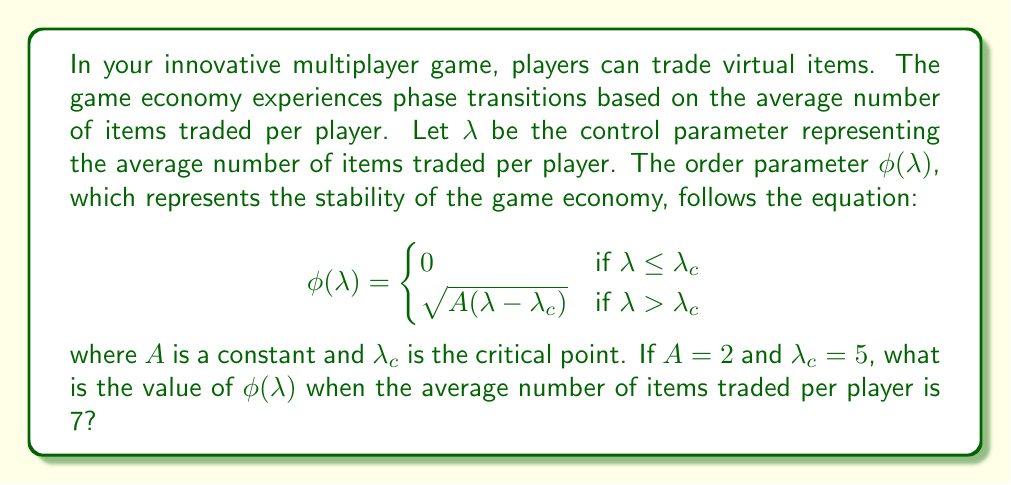Could you help me with this problem? Let's approach this step-by-step:

1) We're given that $A = 2$ and $\lambda_c = 5$.

2) We need to find $\phi(\lambda)$ when $\lambda = 7$.

3) First, we need to determine which case of the piecewise function we're in:
   $\lambda = 7$ and $\lambda_c = 5$
   Since $7 > 5$, we're in the case where $\lambda > \lambda_c$

4) Therefore, we use the equation:
   $$\phi(\lambda) = \sqrt{A(\lambda - \lambda_c)}$$

5) Substituting the values:
   $$\phi(7) = \sqrt{2(7 - 5)}$$

6) Simplify inside the parentheses:
   $$\phi(7) = \sqrt{2(2)}$$

7) Multiply:
   $$\phi(7) = \sqrt{4}$$

8) Simplify the square root:
   $$\phi(7) = 2$$

Thus, when the average number of items traded per player is 7, the order parameter $\phi(\lambda)$ equals 2.
Answer: 2 